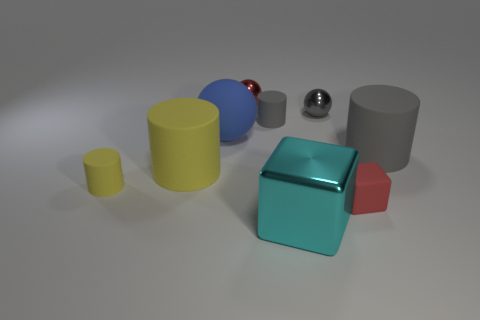Add 1 tiny objects. How many objects exist? 10 Subtract all blocks. How many objects are left? 7 Add 9 large cyan things. How many large cyan things exist? 10 Subtract 1 yellow cylinders. How many objects are left? 8 Subtract all small red metal balls. Subtract all gray matte cylinders. How many objects are left? 6 Add 2 metallic cubes. How many metallic cubes are left? 3 